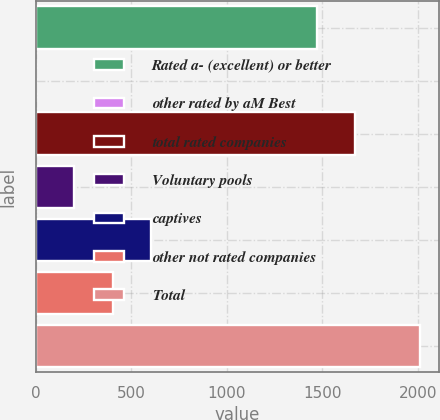Convert chart. <chart><loc_0><loc_0><loc_500><loc_500><bar_chart><fcel>Rated a- (excellent) or better<fcel>other rated by aM Best<fcel>total rated companies<fcel>Voluntary pools<fcel>captives<fcel>other not rated companies<fcel>Total<nl><fcel>1470<fcel>1<fcel>1670.9<fcel>201.9<fcel>603.7<fcel>402.8<fcel>2010<nl></chart> 